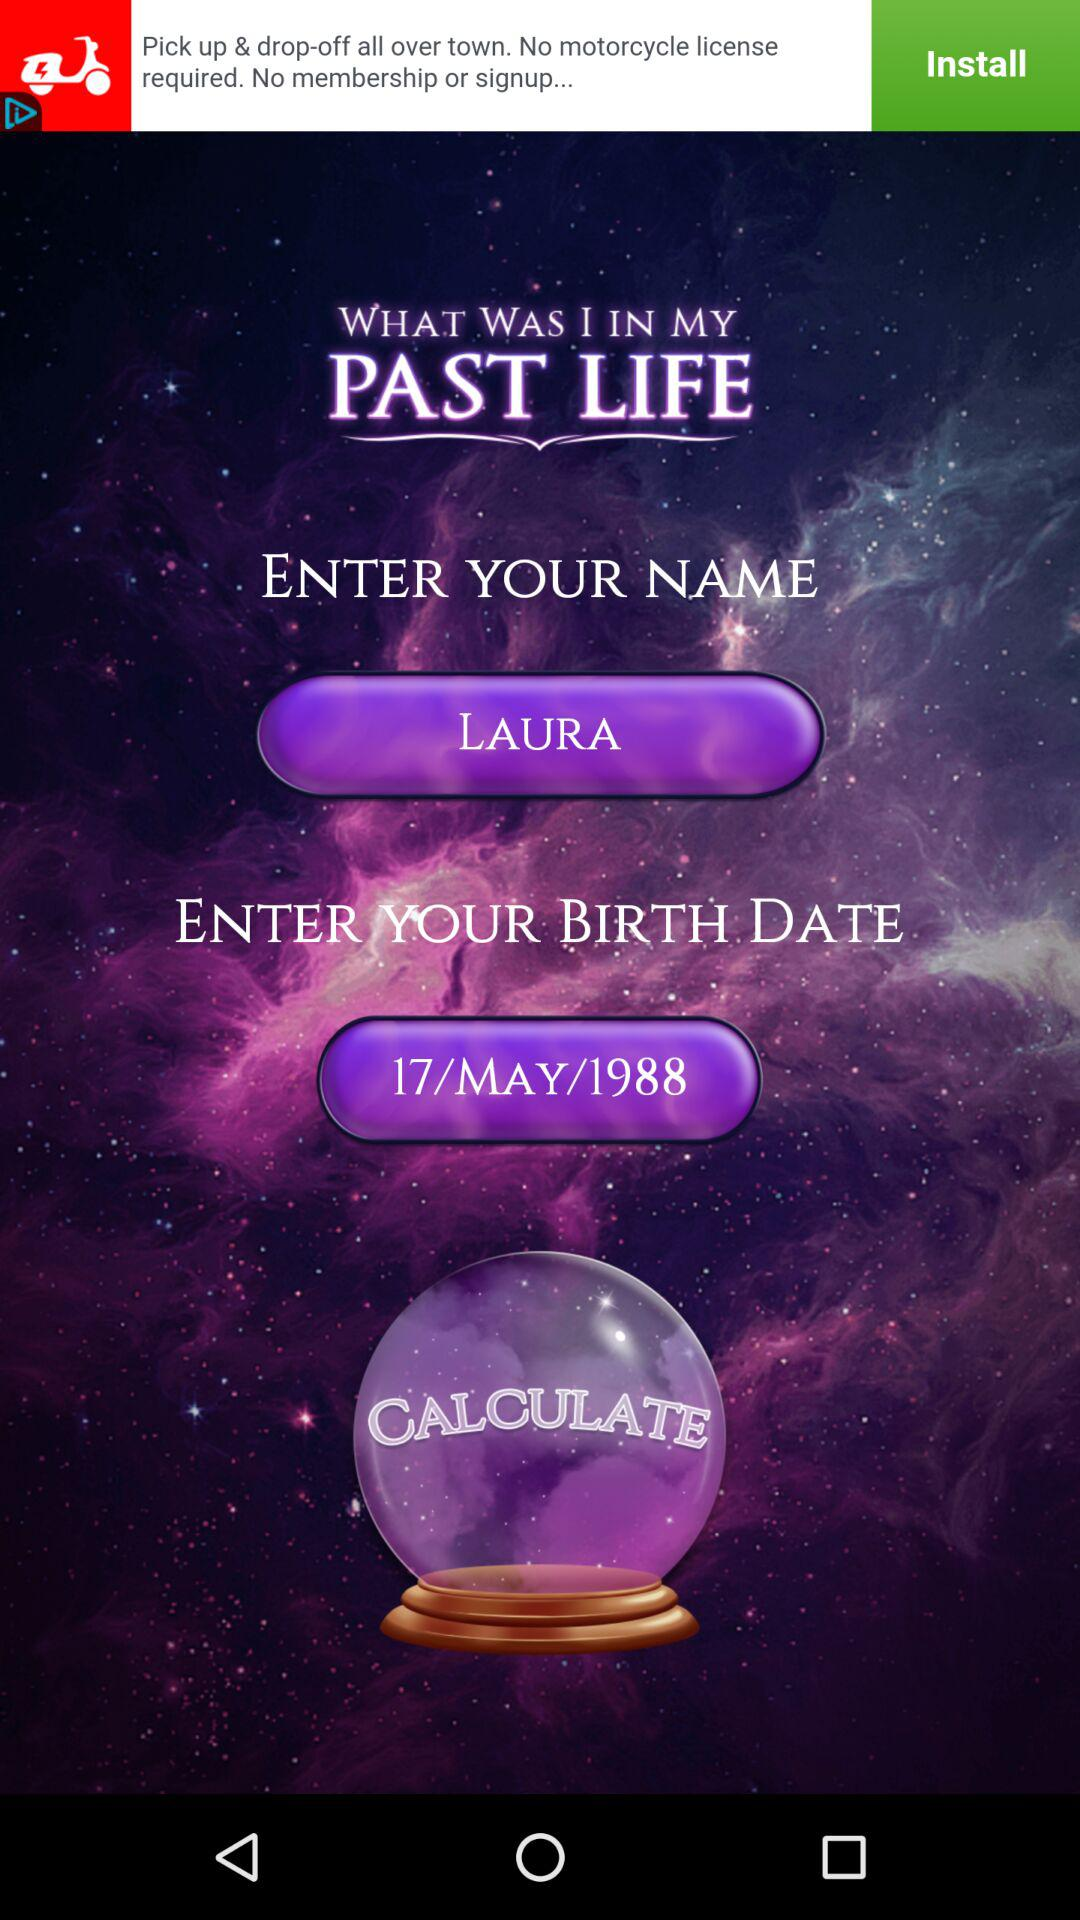What is the name? The name is Laura. 